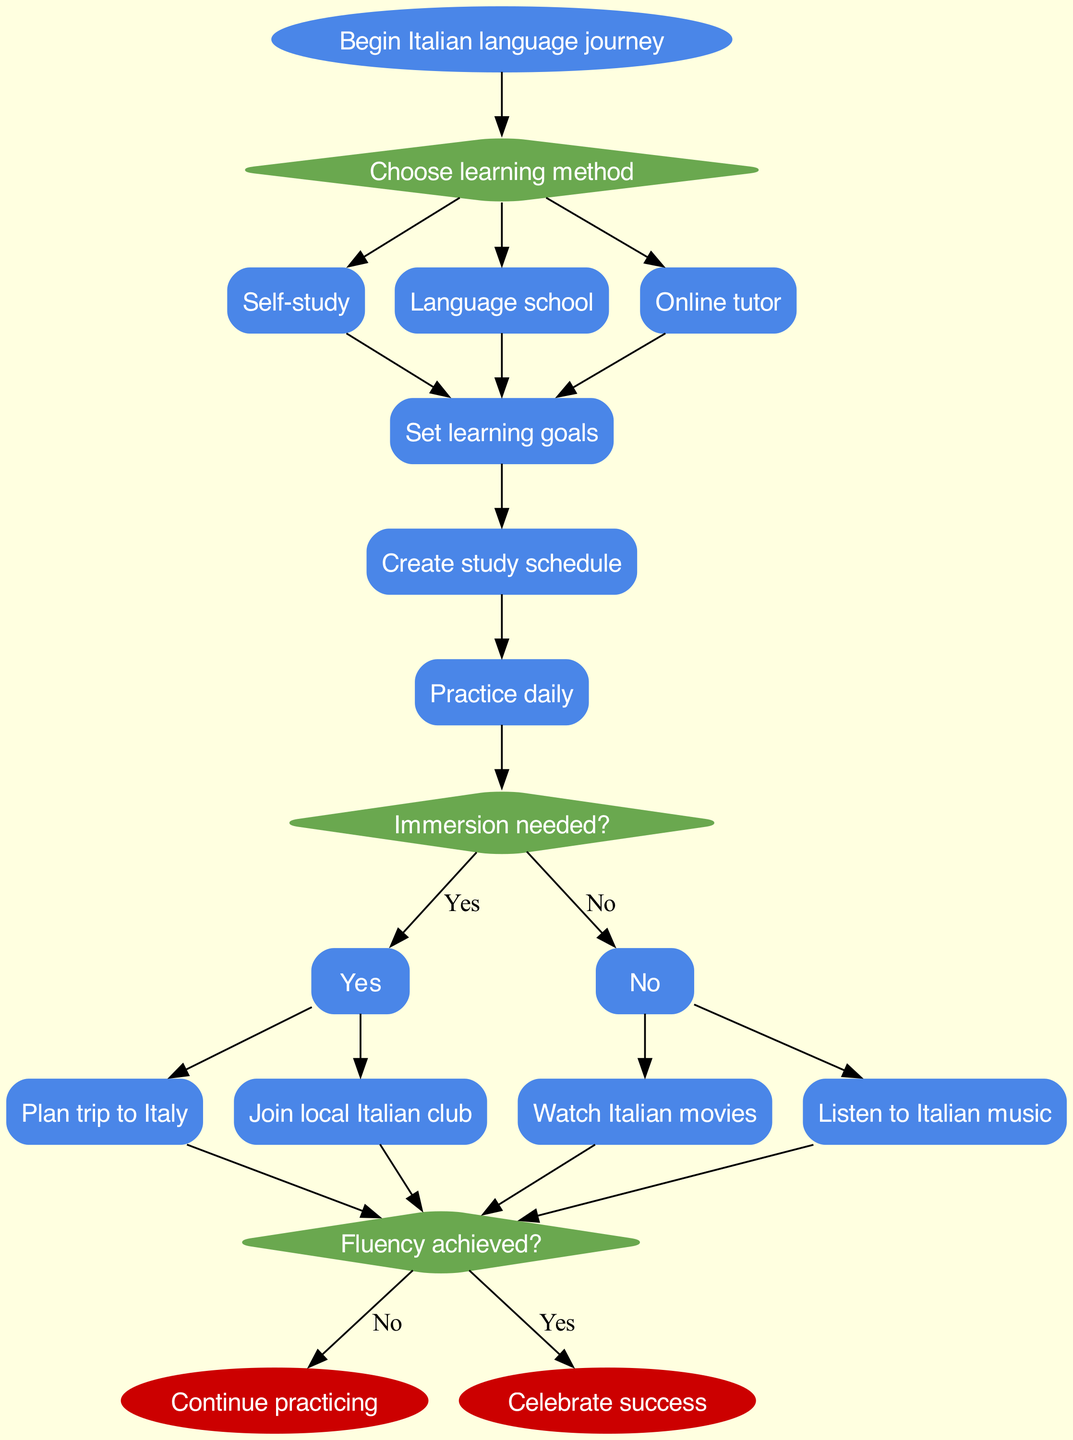What is the starting point of the journey? The starting point is labeled as "Begin Italian language journey". This label directly identifies the initial node in the diagram.
Answer: Begin Italian language journey How many options are available in the first decision? The first decision node presents three options (self-study, language school, online tutor). By reviewing the edges from this decision node, we find three distinct paths leading to these options.
Answer: Three What is the first process that follows the learning method? The first process after choosing a learning method is "Set learning goals". It is directly connected to the options of self-study, language school, and online tutor.
Answer: Set learning goals What happens if immersion is not needed? If immersion is not needed, the flow indicates that one should join a local Italian club and watch Italian movies or listen to Italian music. This outcome is represented by the "No" option from the immersion decision.
Answer: Join local Italian club What is the last decision point in the flow chart? The last decision point is "Fluency achieved?". This is the final diamond-shaped node before reaching the end nodes, which determine the flow's conclusion based on the achievement of fluency.
Answer: Fluency achieved? How does the flow progress if the answer to immersion is "Yes"? If immersion is answered "Yes", the flow leads to planning a trip to Italy and potentially joining a local Italian club, after which it moves toward the final decision about fluency. This is a sequential decision-making process driven by the "Yes" path.
Answer: Plan trip to Italy What do you do if you achieve fluency? If fluency is achieved, the flow chart indicates to "Celebrate success". This is the concluding point for those who successfully reach fluency according to the diagram's structure.
Answer: Celebrate success What must you do immediately after "Set learning goals"? Immediately after "Set learning goals", the next step is to "Create study schedule". This process follows in a linear fashion after establishing the learning objectives.
Answer: Create study schedule What is indicated by the option labeled "Self-study"? The option labeled "Self-study" suggests a method of learning independently, which branches off from the first decision point in the chart. It leads to subsequent processes but does not indicate group learning settings.
Answer: Self-study 